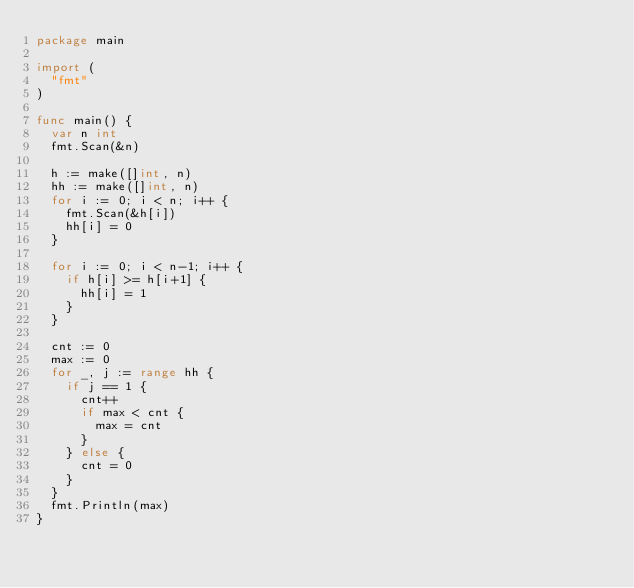<code> <loc_0><loc_0><loc_500><loc_500><_Go_>package main

import (
	"fmt"
)

func main() {
	var n int
	fmt.Scan(&n)

	h := make([]int, n)
	hh := make([]int, n)
	for i := 0; i < n; i++ {
		fmt.Scan(&h[i])
		hh[i] = 0
	}

	for i := 0; i < n-1; i++ {
		if h[i] >= h[i+1] {
			hh[i] = 1
		}
	}

	cnt := 0
	max := 0
	for _, j := range hh {
		if j == 1 {
			cnt++
			if max < cnt {
				max = cnt
			}
		} else {
			cnt = 0
		}
	}
	fmt.Println(max)
}
</code> 